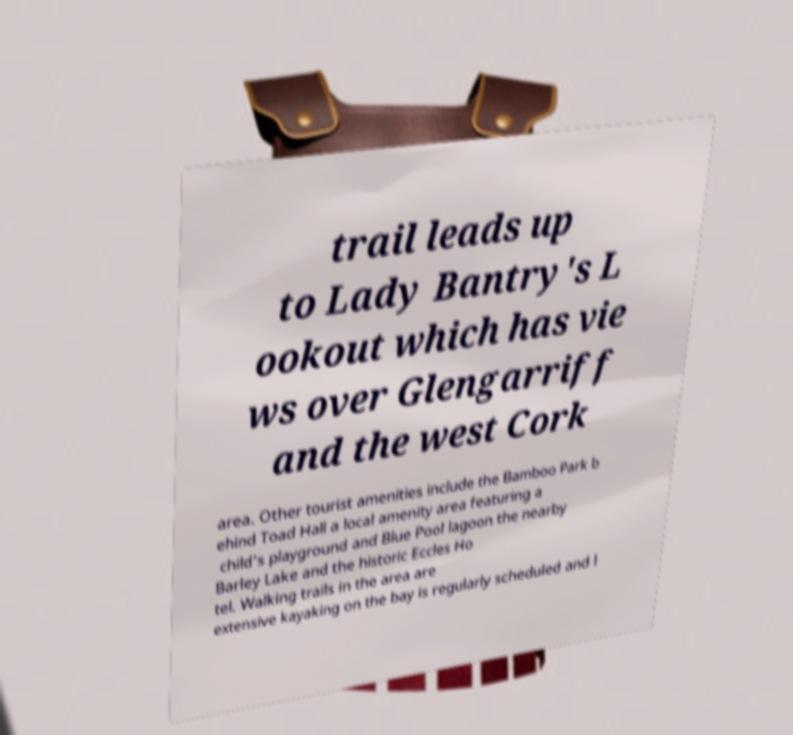For documentation purposes, I need the text within this image transcribed. Could you provide that? trail leads up to Lady Bantry's L ookout which has vie ws over Glengarriff and the west Cork area. Other tourist amenities include the Bamboo Park b ehind Toad Hall a local amenity area featuring a child's playground and Blue Pool lagoon the nearby Barley Lake and the historic Eccles Ho tel. Walking trails in the area are extensive kayaking on the bay is regularly scheduled and l 